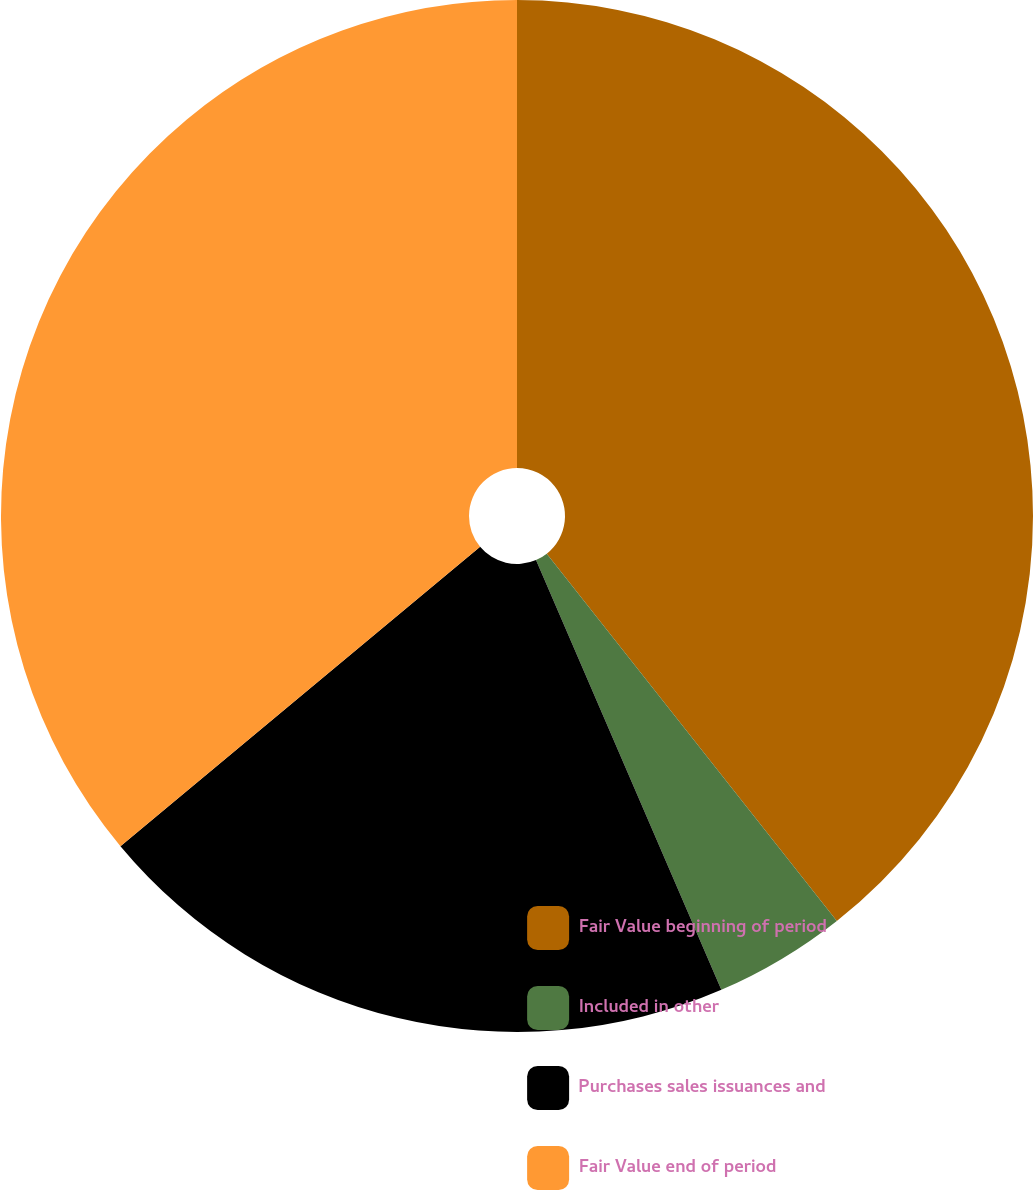Convert chart. <chart><loc_0><loc_0><loc_500><loc_500><pie_chart><fcel>Fair Value beginning of period<fcel>Included in other<fcel>Purchases sales issuances and<fcel>Fair Value end of period<nl><fcel>39.36%<fcel>4.16%<fcel>20.43%<fcel>36.05%<nl></chart> 